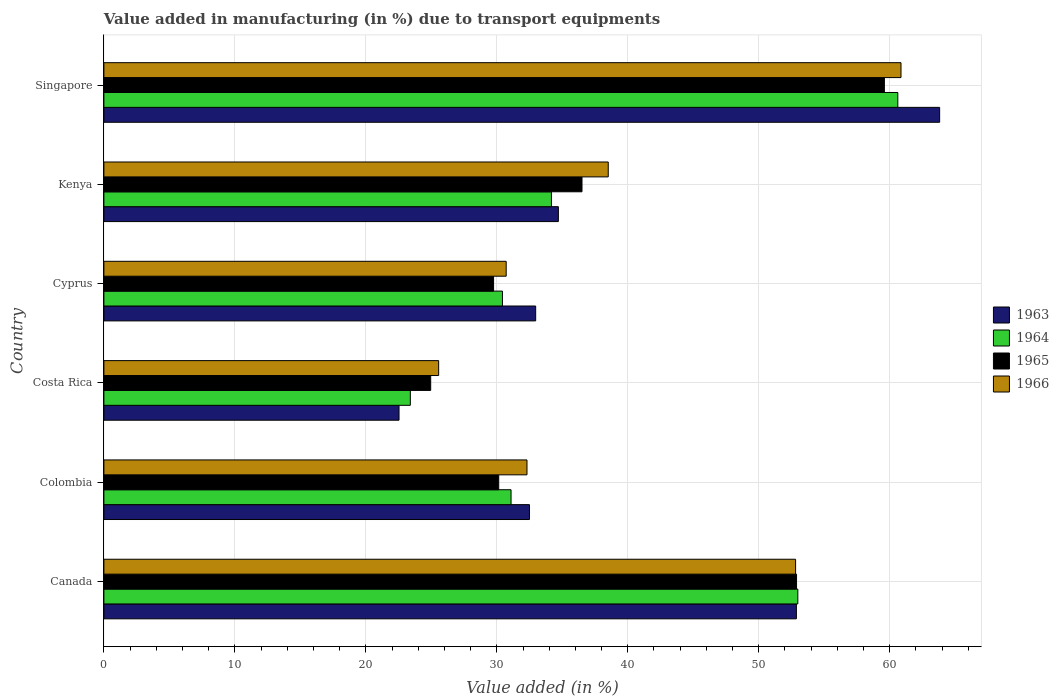How many groups of bars are there?
Offer a terse response. 6. Are the number of bars per tick equal to the number of legend labels?
Make the answer very short. Yes. Are the number of bars on each tick of the Y-axis equal?
Give a very brief answer. Yes. What is the label of the 1st group of bars from the top?
Provide a succinct answer. Singapore. In how many cases, is the number of bars for a given country not equal to the number of legend labels?
Provide a succinct answer. 0. What is the percentage of value added in manufacturing due to transport equipments in 1964 in Singapore?
Give a very brief answer. 60.62. Across all countries, what is the maximum percentage of value added in manufacturing due to transport equipments in 1965?
Offer a terse response. 59.59. Across all countries, what is the minimum percentage of value added in manufacturing due to transport equipments in 1966?
Offer a very short reply. 25.56. In which country was the percentage of value added in manufacturing due to transport equipments in 1965 maximum?
Provide a short and direct response. Singapore. What is the total percentage of value added in manufacturing due to transport equipments in 1966 in the graph?
Provide a short and direct response. 240.76. What is the difference between the percentage of value added in manufacturing due to transport equipments in 1963 in Canada and that in Singapore?
Give a very brief answer. -10.94. What is the difference between the percentage of value added in manufacturing due to transport equipments in 1965 in Costa Rica and the percentage of value added in manufacturing due to transport equipments in 1966 in Canada?
Your answer should be compact. -27.86. What is the average percentage of value added in manufacturing due to transport equipments in 1966 per country?
Your answer should be compact. 40.13. What is the difference between the percentage of value added in manufacturing due to transport equipments in 1965 and percentage of value added in manufacturing due to transport equipments in 1966 in Singapore?
Provide a short and direct response. -1.27. What is the ratio of the percentage of value added in manufacturing due to transport equipments in 1964 in Canada to that in Costa Rica?
Your response must be concise. 2.26. Is the percentage of value added in manufacturing due to transport equipments in 1965 in Colombia less than that in Cyprus?
Your answer should be compact. No. What is the difference between the highest and the second highest percentage of value added in manufacturing due to transport equipments in 1966?
Your answer should be very brief. 8.05. What is the difference between the highest and the lowest percentage of value added in manufacturing due to transport equipments in 1966?
Your answer should be compact. 35.3. In how many countries, is the percentage of value added in manufacturing due to transport equipments in 1966 greater than the average percentage of value added in manufacturing due to transport equipments in 1966 taken over all countries?
Make the answer very short. 2. What does the 3rd bar from the top in Colombia represents?
Provide a short and direct response. 1964. What does the 4th bar from the bottom in Singapore represents?
Your response must be concise. 1966. Does the graph contain any zero values?
Your answer should be very brief. No. Does the graph contain grids?
Provide a succinct answer. Yes. Where does the legend appear in the graph?
Ensure brevity in your answer.  Center right. How are the legend labels stacked?
Ensure brevity in your answer.  Vertical. What is the title of the graph?
Give a very brief answer. Value added in manufacturing (in %) due to transport equipments. What is the label or title of the X-axis?
Your answer should be compact. Value added (in %). What is the label or title of the Y-axis?
Your answer should be very brief. Country. What is the Value added (in %) of 1963 in Canada?
Ensure brevity in your answer.  52.87. What is the Value added (in %) in 1964 in Canada?
Ensure brevity in your answer.  52.98. What is the Value added (in %) in 1965 in Canada?
Your response must be concise. 52.89. What is the Value added (in %) in 1966 in Canada?
Keep it short and to the point. 52.81. What is the Value added (in %) of 1963 in Colombia?
Give a very brief answer. 32.49. What is the Value added (in %) in 1964 in Colombia?
Your answer should be compact. 31.09. What is the Value added (in %) in 1965 in Colombia?
Provide a succinct answer. 30.15. What is the Value added (in %) in 1966 in Colombia?
Ensure brevity in your answer.  32.3. What is the Value added (in %) in 1963 in Costa Rica?
Your response must be concise. 22.53. What is the Value added (in %) of 1964 in Costa Rica?
Offer a terse response. 23.4. What is the Value added (in %) in 1965 in Costa Rica?
Your response must be concise. 24.95. What is the Value added (in %) of 1966 in Costa Rica?
Your response must be concise. 25.56. What is the Value added (in %) in 1963 in Cyprus?
Provide a short and direct response. 32.97. What is the Value added (in %) in 1964 in Cyprus?
Your response must be concise. 30.43. What is the Value added (in %) of 1965 in Cyprus?
Offer a very short reply. 29.75. What is the Value added (in %) of 1966 in Cyprus?
Your answer should be compact. 30.72. What is the Value added (in %) of 1963 in Kenya?
Ensure brevity in your answer.  34.7. What is the Value added (in %) in 1964 in Kenya?
Your answer should be compact. 34.17. What is the Value added (in %) in 1965 in Kenya?
Keep it short and to the point. 36.5. What is the Value added (in %) in 1966 in Kenya?
Keep it short and to the point. 38.51. What is the Value added (in %) in 1963 in Singapore?
Give a very brief answer. 63.81. What is the Value added (in %) of 1964 in Singapore?
Your answer should be very brief. 60.62. What is the Value added (in %) of 1965 in Singapore?
Ensure brevity in your answer.  59.59. What is the Value added (in %) in 1966 in Singapore?
Offer a terse response. 60.86. Across all countries, what is the maximum Value added (in %) in 1963?
Your answer should be very brief. 63.81. Across all countries, what is the maximum Value added (in %) in 1964?
Give a very brief answer. 60.62. Across all countries, what is the maximum Value added (in %) in 1965?
Provide a short and direct response. 59.59. Across all countries, what is the maximum Value added (in %) of 1966?
Provide a succinct answer. 60.86. Across all countries, what is the minimum Value added (in %) in 1963?
Keep it short and to the point. 22.53. Across all countries, what is the minimum Value added (in %) of 1964?
Ensure brevity in your answer.  23.4. Across all countries, what is the minimum Value added (in %) of 1965?
Provide a short and direct response. 24.95. Across all countries, what is the minimum Value added (in %) of 1966?
Give a very brief answer. 25.56. What is the total Value added (in %) in 1963 in the graph?
Your answer should be very brief. 239.38. What is the total Value added (in %) in 1964 in the graph?
Give a very brief answer. 232.68. What is the total Value added (in %) in 1965 in the graph?
Give a very brief answer. 233.83. What is the total Value added (in %) of 1966 in the graph?
Give a very brief answer. 240.76. What is the difference between the Value added (in %) of 1963 in Canada and that in Colombia?
Your response must be concise. 20.38. What is the difference between the Value added (in %) in 1964 in Canada and that in Colombia?
Your answer should be very brief. 21.9. What is the difference between the Value added (in %) in 1965 in Canada and that in Colombia?
Your response must be concise. 22.74. What is the difference between the Value added (in %) in 1966 in Canada and that in Colombia?
Give a very brief answer. 20.51. What is the difference between the Value added (in %) of 1963 in Canada and that in Costa Rica?
Give a very brief answer. 30.34. What is the difference between the Value added (in %) of 1964 in Canada and that in Costa Rica?
Offer a very short reply. 29.59. What is the difference between the Value added (in %) in 1965 in Canada and that in Costa Rica?
Provide a succinct answer. 27.93. What is the difference between the Value added (in %) in 1966 in Canada and that in Costa Rica?
Your answer should be very brief. 27.25. What is the difference between the Value added (in %) of 1963 in Canada and that in Cyprus?
Your answer should be compact. 19.91. What is the difference between the Value added (in %) of 1964 in Canada and that in Cyprus?
Give a very brief answer. 22.55. What is the difference between the Value added (in %) in 1965 in Canada and that in Cyprus?
Provide a succinct answer. 23.13. What is the difference between the Value added (in %) in 1966 in Canada and that in Cyprus?
Make the answer very short. 22.1. What is the difference between the Value added (in %) of 1963 in Canada and that in Kenya?
Offer a very short reply. 18.17. What is the difference between the Value added (in %) of 1964 in Canada and that in Kenya?
Make the answer very short. 18.81. What is the difference between the Value added (in %) in 1965 in Canada and that in Kenya?
Give a very brief answer. 16.38. What is the difference between the Value added (in %) in 1966 in Canada and that in Kenya?
Offer a terse response. 14.3. What is the difference between the Value added (in %) of 1963 in Canada and that in Singapore?
Provide a succinct answer. -10.94. What is the difference between the Value added (in %) in 1964 in Canada and that in Singapore?
Your response must be concise. -7.63. What is the difference between the Value added (in %) in 1965 in Canada and that in Singapore?
Offer a very short reply. -6.71. What is the difference between the Value added (in %) in 1966 in Canada and that in Singapore?
Your response must be concise. -8.05. What is the difference between the Value added (in %) in 1963 in Colombia and that in Costa Rica?
Keep it short and to the point. 9.96. What is the difference between the Value added (in %) of 1964 in Colombia and that in Costa Rica?
Ensure brevity in your answer.  7.69. What is the difference between the Value added (in %) of 1965 in Colombia and that in Costa Rica?
Your answer should be very brief. 5.2. What is the difference between the Value added (in %) in 1966 in Colombia and that in Costa Rica?
Give a very brief answer. 6.74. What is the difference between the Value added (in %) in 1963 in Colombia and that in Cyprus?
Keep it short and to the point. -0.47. What is the difference between the Value added (in %) in 1964 in Colombia and that in Cyprus?
Your answer should be very brief. 0.66. What is the difference between the Value added (in %) of 1965 in Colombia and that in Cyprus?
Your answer should be compact. 0.39. What is the difference between the Value added (in %) of 1966 in Colombia and that in Cyprus?
Your response must be concise. 1.59. What is the difference between the Value added (in %) of 1963 in Colombia and that in Kenya?
Your response must be concise. -2.21. What is the difference between the Value added (in %) of 1964 in Colombia and that in Kenya?
Offer a terse response. -3.08. What is the difference between the Value added (in %) of 1965 in Colombia and that in Kenya?
Your response must be concise. -6.36. What is the difference between the Value added (in %) of 1966 in Colombia and that in Kenya?
Provide a short and direct response. -6.2. What is the difference between the Value added (in %) in 1963 in Colombia and that in Singapore?
Your response must be concise. -31.32. What is the difference between the Value added (in %) of 1964 in Colombia and that in Singapore?
Your answer should be compact. -29.53. What is the difference between the Value added (in %) of 1965 in Colombia and that in Singapore?
Provide a succinct answer. -29.45. What is the difference between the Value added (in %) of 1966 in Colombia and that in Singapore?
Ensure brevity in your answer.  -28.56. What is the difference between the Value added (in %) of 1963 in Costa Rica and that in Cyprus?
Your answer should be very brief. -10.43. What is the difference between the Value added (in %) in 1964 in Costa Rica and that in Cyprus?
Give a very brief answer. -7.03. What is the difference between the Value added (in %) of 1965 in Costa Rica and that in Cyprus?
Ensure brevity in your answer.  -4.8. What is the difference between the Value added (in %) in 1966 in Costa Rica and that in Cyprus?
Keep it short and to the point. -5.16. What is the difference between the Value added (in %) of 1963 in Costa Rica and that in Kenya?
Offer a terse response. -12.17. What is the difference between the Value added (in %) in 1964 in Costa Rica and that in Kenya?
Offer a very short reply. -10.77. What is the difference between the Value added (in %) in 1965 in Costa Rica and that in Kenya?
Provide a succinct answer. -11.55. What is the difference between the Value added (in %) in 1966 in Costa Rica and that in Kenya?
Ensure brevity in your answer.  -12.95. What is the difference between the Value added (in %) of 1963 in Costa Rica and that in Singapore?
Your answer should be very brief. -41.28. What is the difference between the Value added (in %) of 1964 in Costa Rica and that in Singapore?
Offer a very short reply. -37.22. What is the difference between the Value added (in %) of 1965 in Costa Rica and that in Singapore?
Offer a terse response. -34.64. What is the difference between the Value added (in %) of 1966 in Costa Rica and that in Singapore?
Your response must be concise. -35.3. What is the difference between the Value added (in %) of 1963 in Cyprus and that in Kenya?
Your answer should be very brief. -1.73. What is the difference between the Value added (in %) in 1964 in Cyprus and that in Kenya?
Provide a short and direct response. -3.74. What is the difference between the Value added (in %) in 1965 in Cyprus and that in Kenya?
Ensure brevity in your answer.  -6.75. What is the difference between the Value added (in %) of 1966 in Cyprus and that in Kenya?
Provide a succinct answer. -7.79. What is the difference between the Value added (in %) of 1963 in Cyprus and that in Singapore?
Provide a succinct answer. -30.84. What is the difference between the Value added (in %) of 1964 in Cyprus and that in Singapore?
Your answer should be compact. -30.19. What is the difference between the Value added (in %) in 1965 in Cyprus and that in Singapore?
Offer a terse response. -29.84. What is the difference between the Value added (in %) of 1966 in Cyprus and that in Singapore?
Ensure brevity in your answer.  -30.14. What is the difference between the Value added (in %) in 1963 in Kenya and that in Singapore?
Give a very brief answer. -29.11. What is the difference between the Value added (in %) of 1964 in Kenya and that in Singapore?
Give a very brief answer. -26.45. What is the difference between the Value added (in %) in 1965 in Kenya and that in Singapore?
Keep it short and to the point. -23.09. What is the difference between the Value added (in %) of 1966 in Kenya and that in Singapore?
Offer a very short reply. -22.35. What is the difference between the Value added (in %) in 1963 in Canada and the Value added (in %) in 1964 in Colombia?
Provide a short and direct response. 21.79. What is the difference between the Value added (in %) in 1963 in Canada and the Value added (in %) in 1965 in Colombia?
Make the answer very short. 22.73. What is the difference between the Value added (in %) in 1963 in Canada and the Value added (in %) in 1966 in Colombia?
Provide a short and direct response. 20.57. What is the difference between the Value added (in %) of 1964 in Canada and the Value added (in %) of 1965 in Colombia?
Ensure brevity in your answer.  22.84. What is the difference between the Value added (in %) of 1964 in Canada and the Value added (in %) of 1966 in Colombia?
Offer a terse response. 20.68. What is the difference between the Value added (in %) of 1965 in Canada and the Value added (in %) of 1966 in Colombia?
Your response must be concise. 20.58. What is the difference between the Value added (in %) in 1963 in Canada and the Value added (in %) in 1964 in Costa Rica?
Keep it short and to the point. 29.48. What is the difference between the Value added (in %) in 1963 in Canada and the Value added (in %) in 1965 in Costa Rica?
Provide a short and direct response. 27.92. What is the difference between the Value added (in %) of 1963 in Canada and the Value added (in %) of 1966 in Costa Rica?
Offer a terse response. 27.31. What is the difference between the Value added (in %) in 1964 in Canada and the Value added (in %) in 1965 in Costa Rica?
Provide a succinct answer. 28.03. What is the difference between the Value added (in %) in 1964 in Canada and the Value added (in %) in 1966 in Costa Rica?
Provide a short and direct response. 27.42. What is the difference between the Value added (in %) of 1965 in Canada and the Value added (in %) of 1966 in Costa Rica?
Give a very brief answer. 27.33. What is the difference between the Value added (in %) of 1963 in Canada and the Value added (in %) of 1964 in Cyprus?
Provide a short and direct response. 22.44. What is the difference between the Value added (in %) in 1963 in Canada and the Value added (in %) in 1965 in Cyprus?
Offer a terse response. 23.12. What is the difference between the Value added (in %) of 1963 in Canada and the Value added (in %) of 1966 in Cyprus?
Offer a very short reply. 22.16. What is the difference between the Value added (in %) in 1964 in Canada and the Value added (in %) in 1965 in Cyprus?
Offer a very short reply. 23.23. What is the difference between the Value added (in %) in 1964 in Canada and the Value added (in %) in 1966 in Cyprus?
Make the answer very short. 22.27. What is the difference between the Value added (in %) of 1965 in Canada and the Value added (in %) of 1966 in Cyprus?
Offer a terse response. 22.17. What is the difference between the Value added (in %) of 1963 in Canada and the Value added (in %) of 1964 in Kenya?
Your answer should be compact. 18.7. What is the difference between the Value added (in %) in 1963 in Canada and the Value added (in %) in 1965 in Kenya?
Your answer should be compact. 16.37. What is the difference between the Value added (in %) in 1963 in Canada and the Value added (in %) in 1966 in Kenya?
Make the answer very short. 14.37. What is the difference between the Value added (in %) in 1964 in Canada and the Value added (in %) in 1965 in Kenya?
Provide a succinct answer. 16.48. What is the difference between the Value added (in %) of 1964 in Canada and the Value added (in %) of 1966 in Kenya?
Your answer should be compact. 14.47. What is the difference between the Value added (in %) in 1965 in Canada and the Value added (in %) in 1966 in Kenya?
Provide a short and direct response. 14.38. What is the difference between the Value added (in %) of 1963 in Canada and the Value added (in %) of 1964 in Singapore?
Make the answer very short. -7.74. What is the difference between the Value added (in %) of 1963 in Canada and the Value added (in %) of 1965 in Singapore?
Provide a short and direct response. -6.72. What is the difference between the Value added (in %) in 1963 in Canada and the Value added (in %) in 1966 in Singapore?
Ensure brevity in your answer.  -7.99. What is the difference between the Value added (in %) in 1964 in Canada and the Value added (in %) in 1965 in Singapore?
Offer a terse response. -6.61. What is the difference between the Value added (in %) of 1964 in Canada and the Value added (in %) of 1966 in Singapore?
Provide a short and direct response. -7.88. What is the difference between the Value added (in %) in 1965 in Canada and the Value added (in %) in 1966 in Singapore?
Provide a short and direct response. -7.97. What is the difference between the Value added (in %) in 1963 in Colombia and the Value added (in %) in 1964 in Costa Rica?
Ensure brevity in your answer.  9.1. What is the difference between the Value added (in %) in 1963 in Colombia and the Value added (in %) in 1965 in Costa Rica?
Provide a short and direct response. 7.54. What is the difference between the Value added (in %) of 1963 in Colombia and the Value added (in %) of 1966 in Costa Rica?
Your response must be concise. 6.93. What is the difference between the Value added (in %) of 1964 in Colombia and the Value added (in %) of 1965 in Costa Rica?
Give a very brief answer. 6.14. What is the difference between the Value added (in %) in 1964 in Colombia and the Value added (in %) in 1966 in Costa Rica?
Provide a short and direct response. 5.53. What is the difference between the Value added (in %) of 1965 in Colombia and the Value added (in %) of 1966 in Costa Rica?
Make the answer very short. 4.59. What is the difference between the Value added (in %) in 1963 in Colombia and the Value added (in %) in 1964 in Cyprus?
Provide a succinct answer. 2.06. What is the difference between the Value added (in %) in 1963 in Colombia and the Value added (in %) in 1965 in Cyprus?
Give a very brief answer. 2.74. What is the difference between the Value added (in %) of 1963 in Colombia and the Value added (in %) of 1966 in Cyprus?
Provide a short and direct response. 1.78. What is the difference between the Value added (in %) of 1964 in Colombia and the Value added (in %) of 1965 in Cyprus?
Your answer should be compact. 1.33. What is the difference between the Value added (in %) in 1964 in Colombia and the Value added (in %) in 1966 in Cyprus?
Provide a succinct answer. 0.37. What is the difference between the Value added (in %) of 1965 in Colombia and the Value added (in %) of 1966 in Cyprus?
Provide a short and direct response. -0.57. What is the difference between the Value added (in %) in 1963 in Colombia and the Value added (in %) in 1964 in Kenya?
Offer a terse response. -1.68. What is the difference between the Value added (in %) of 1963 in Colombia and the Value added (in %) of 1965 in Kenya?
Provide a succinct answer. -4.01. What is the difference between the Value added (in %) in 1963 in Colombia and the Value added (in %) in 1966 in Kenya?
Your response must be concise. -6.01. What is the difference between the Value added (in %) in 1964 in Colombia and the Value added (in %) in 1965 in Kenya?
Provide a succinct answer. -5.42. What is the difference between the Value added (in %) of 1964 in Colombia and the Value added (in %) of 1966 in Kenya?
Offer a terse response. -7.42. What is the difference between the Value added (in %) of 1965 in Colombia and the Value added (in %) of 1966 in Kenya?
Keep it short and to the point. -8.36. What is the difference between the Value added (in %) in 1963 in Colombia and the Value added (in %) in 1964 in Singapore?
Make the answer very short. -28.12. What is the difference between the Value added (in %) of 1963 in Colombia and the Value added (in %) of 1965 in Singapore?
Keep it short and to the point. -27.1. What is the difference between the Value added (in %) in 1963 in Colombia and the Value added (in %) in 1966 in Singapore?
Your response must be concise. -28.37. What is the difference between the Value added (in %) of 1964 in Colombia and the Value added (in %) of 1965 in Singapore?
Your answer should be compact. -28.51. What is the difference between the Value added (in %) of 1964 in Colombia and the Value added (in %) of 1966 in Singapore?
Ensure brevity in your answer.  -29.77. What is the difference between the Value added (in %) in 1965 in Colombia and the Value added (in %) in 1966 in Singapore?
Offer a very short reply. -30.71. What is the difference between the Value added (in %) of 1963 in Costa Rica and the Value added (in %) of 1964 in Cyprus?
Offer a very short reply. -7.9. What is the difference between the Value added (in %) in 1963 in Costa Rica and the Value added (in %) in 1965 in Cyprus?
Your answer should be compact. -7.22. What is the difference between the Value added (in %) in 1963 in Costa Rica and the Value added (in %) in 1966 in Cyprus?
Provide a short and direct response. -8.18. What is the difference between the Value added (in %) of 1964 in Costa Rica and the Value added (in %) of 1965 in Cyprus?
Your answer should be compact. -6.36. What is the difference between the Value added (in %) in 1964 in Costa Rica and the Value added (in %) in 1966 in Cyprus?
Provide a succinct answer. -7.32. What is the difference between the Value added (in %) in 1965 in Costa Rica and the Value added (in %) in 1966 in Cyprus?
Make the answer very short. -5.77. What is the difference between the Value added (in %) of 1963 in Costa Rica and the Value added (in %) of 1964 in Kenya?
Your answer should be very brief. -11.64. What is the difference between the Value added (in %) in 1963 in Costa Rica and the Value added (in %) in 1965 in Kenya?
Provide a succinct answer. -13.97. What is the difference between the Value added (in %) of 1963 in Costa Rica and the Value added (in %) of 1966 in Kenya?
Provide a succinct answer. -15.97. What is the difference between the Value added (in %) in 1964 in Costa Rica and the Value added (in %) in 1965 in Kenya?
Your answer should be very brief. -13.11. What is the difference between the Value added (in %) in 1964 in Costa Rica and the Value added (in %) in 1966 in Kenya?
Your answer should be compact. -15.11. What is the difference between the Value added (in %) of 1965 in Costa Rica and the Value added (in %) of 1966 in Kenya?
Make the answer very short. -13.56. What is the difference between the Value added (in %) of 1963 in Costa Rica and the Value added (in %) of 1964 in Singapore?
Your answer should be very brief. -38.08. What is the difference between the Value added (in %) in 1963 in Costa Rica and the Value added (in %) in 1965 in Singapore?
Your answer should be very brief. -37.06. What is the difference between the Value added (in %) of 1963 in Costa Rica and the Value added (in %) of 1966 in Singapore?
Provide a succinct answer. -38.33. What is the difference between the Value added (in %) of 1964 in Costa Rica and the Value added (in %) of 1965 in Singapore?
Your answer should be compact. -36.19. What is the difference between the Value added (in %) of 1964 in Costa Rica and the Value added (in %) of 1966 in Singapore?
Give a very brief answer. -37.46. What is the difference between the Value added (in %) of 1965 in Costa Rica and the Value added (in %) of 1966 in Singapore?
Keep it short and to the point. -35.91. What is the difference between the Value added (in %) of 1963 in Cyprus and the Value added (in %) of 1964 in Kenya?
Your answer should be compact. -1.2. What is the difference between the Value added (in %) of 1963 in Cyprus and the Value added (in %) of 1965 in Kenya?
Keep it short and to the point. -3.54. What is the difference between the Value added (in %) of 1963 in Cyprus and the Value added (in %) of 1966 in Kenya?
Offer a terse response. -5.54. What is the difference between the Value added (in %) in 1964 in Cyprus and the Value added (in %) in 1965 in Kenya?
Offer a terse response. -6.07. What is the difference between the Value added (in %) of 1964 in Cyprus and the Value added (in %) of 1966 in Kenya?
Offer a very short reply. -8.08. What is the difference between the Value added (in %) of 1965 in Cyprus and the Value added (in %) of 1966 in Kenya?
Give a very brief answer. -8.75. What is the difference between the Value added (in %) of 1963 in Cyprus and the Value added (in %) of 1964 in Singapore?
Make the answer very short. -27.65. What is the difference between the Value added (in %) in 1963 in Cyprus and the Value added (in %) in 1965 in Singapore?
Your response must be concise. -26.62. What is the difference between the Value added (in %) in 1963 in Cyprus and the Value added (in %) in 1966 in Singapore?
Provide a succinct answer. -27.89. What is the difference between the Value added (in %) of 1964 in Cyprus and the Value added (in %) of 1965 in Singapore?
Your response must be concise. -29.16. What is the difference between the Value added (in %) of 1964 in Cyprus and the Value added (in %) of 1966 in Singapore?
Provide a succinct answer. -30.43. What is the difference between the Value added (in %) in 1965 in Cyprus and the Value added (in %) in 1966 in Singapore?
Make the answer very short. -31.11. What is the difference between the Value added (in %) of 1963 in Kenya and the Value added (in %) of 1964 in Singapore?
Your response must be concise. -25.92. What is the difference between the Value added (in %) of 1963 in Kenya and the Value added (in %) of 1965 in Singapore?
Provide a succinct answer. -24.89. What is the difference between the Value added (in %) of 1963 in Kenya and the Value added (in %) of 1966 in Singapore?
Keep it short and to the point. -26.16. What is the difference between the Value added (in %) in 1964 in Kenya and the Value added (in %) in 1965 in Singapore?
Make the answer very short. -25.42. What is the difference between the Value added (in %) of 1964 in Kenya and the Value added (in %) of 1966 in Singapore?
Keep it short and to the point. -26.69. What is the difference between the Value added (in %) of 1965 in Kenya and the Value added (in %) of 1966 in Singapore?
Your answer should be compact. -24.36. What is the average Value added (in %) in 1963 per country?
Keep it short and to the point. 39.9. What is the average Value added (in %) in 1964 per country?
Your answer should be compact. 38.78. What is the average Value added (in %) of 1965 per country?
Offer a very short reply. 38.97. What is the average Value added (in %) of 1966 per country?
Offer a very short reply. 40.13. What is the difference between the Value added (in %) of 1963 and Value added (in %) of 1964 in Canada?
Your answer should be compact. -0.11. What is the difference between the Value added (in %) of 1963 and Value added (in %) of 1965 in Canada?
Give a very brief answer. -0.01. What is the difference between the Value added (in %) of 1963 and Value added (in %) of 1966 in Canada?
Your answer should be compact. 0.06. What is the difference between the Value added (in %) of 1964 and Value added (in %) of 1965 in Canada?
Give a very brief answer. 0.1. What is the difference between the Value added (in %) of 1964 and Value added (in %) of 1966 in Canada?
Provide a short and direct response. 0.17. What is the difference between the Value added (in %) of 1965 and Value added (in %) of 1966 in Canada?
Give a very brief answer. 0.07. What is the difference between the Value added (in %) of 1963 and Value added (in %) of 1964 in Colombia?
Keep it short and to the point. 1.41. What is the difference between the Value added (in %) in 1963 and Value added (in %) in 1965 in Colombia?
Provide a succinct answer. 2.35. What is the difference between the Value added (in %) in 1963 and Value added (in %) in 1966 in Colombia?
Your answer should be very brief. 0.19. What is the difference between the Value added (in %) of 1964 and Value added (in %) of 1965 in Colombia?
Ensure brevity in your answer.  0.94. What is the difference between the Value added (in %) of 1964 and Value added (in %) of 1966 in Colombia?
Provide a succinct answer. -1.22. What is the difference between the Value added (in %) of 1965 and Value added (in %) of 1966 in Colombia?
Provide a succinct answer. -2.16. What is the difference between the Value added (in %) in 1963 and Value added (in %) in 1964 in Costa Rica?
Make the answer very short. -0.86. What is the difference between the Value added (in %) of 1963 and Value added (in %) of 1965 in Costa Rica?
Your response must be concise. -2.42. What is the difference between the Value added (in %) of 1963 and Value added (in %) of 1966 in Costa Rica?
Give a very brief answer. -3.03. What is the difference between the Value added (in %) of 1964 and Value added (in %) of 1965 in Costa Rica?
Give a very brief answer. -1.55. What is the difference between the Value added (in %) in 1964 and Value added (in %) in 1966 in Costa Rica?
Give a very brief answer. -2.16. What is the difference between the Value added (in %) of 1965 and Value added (in %) of 1966 in Costa Rica?
Keep it short and to the point. -0.61. What is the difference between the Value added (in %) of 1963 and Value added (in %) of 1964 in Cyprus?
Ensure brevity in your answer.  2.54. What is the difference between the Value added (in %) in 1963 and Value added (in %) in 1965 in Cyprus?
Your answer should be compact. 3.21. What is the difference between the Value added (in %) in 1963 and Value added (in %) in 1966 in Cyprus?
Make the answer very short. 2.25. What is the difference between the Value added (in %) in 1964 and Value added (in %) in 1965 in Cyprus?
Your answer should be compact. 0.68. What is the difference between the Value added (in %) in 1964 and Value added (in %) in 1966 in Cyprus?
Provide a short and direct response. -0.29. What is the difference between the Value added (in %) of 1965 and Value added (in %) of 1966 in Cyprus?
Keep it short and to the point. -0.96. What is the difference between the Value added (in %) of 1963 and Value added (in %) of 1964 in Kenya?
Ensure brevity in your answer.  0.53. What is the difference between the Value added (in %) in 1963 and Value added (in %) in 1965 in Kenya?
Give a very brief answer. -1.8. What is the difference between the Value added (in %) in 1963 and Value added (in %) in 1966 in Kenya?
Make the answer very short. -3.81. What is the difference between the Value added (in %) of 1964 and Value added (in %) of 1965 in Kenya?
Give a very brief answer. -2.33. What is the difference between the Value added (in %) of 1964 and Value added (in %) of 1966 in Kenya?
Ensure brevity in your answer.  -4.34. What is the difference between the Value added (in %) of 1965 and Value added (in %) of 1966 in Kenya?
Provide a succinct answer. -2. What is the difference between the Value added (in %) in 1963 and Value added (in %) in 1964 in Singapore?
Keep it short and to the point. 3.19. What is the difference between the Value added (in %) of 1963 and Value added (in %) of 1965 in Singapore?
Offer a terse response. 4.22. What is the difference between the Value added (in %) of 1963 and Value added (in %) of 1966 in Singapore?
Your answer should be very brief. 2.95. What is the difference between the Value added (in %) of 1964 and Value added (in %) of 1965 in Singapore?
Ensure brevity in your answer.  1.03. What is the difference between the Value added (in %) in 1964 and Value added (in %) in 1966 in Singapore?
Your answer should be compact. -0.24. What is the difference between the Value added (in %) of 1965 and Value added (in %) of 1966 in Singapore?
Offer a terse response. -1.27. What is the ratio of the Value added (in %) of 1963 in Canada to that in Colombia?
Provide a short and direct response. 1.63. What is the ratio of the Value added (in %) in 1964 in Canada to that in Colombia?
Ensure brevity in your answer.  1.7. What is the ratio of the Value added (in %) in 1965 in Canada to that in Colombia?
Give a very brief answer. 1.75. What is the ratio of the Value added (in %) in 1966 in Canada to that in Colombia?
Your answer should be compact. 1.63. What is the ratio of the Value added (in %) of 1963 in Canada to that in Costa Rica?
Your answer should be very brief. 2.35. What is the ratio of the Value added (in %) of 1964 in Canada to that in Costa Rica?
Your response must be concise. 2.26. What is the ratio of the Value added (in %) of 1965 in Canada to that in Costa Rica?
Provide a succinct answer. 2.12. What is the ratio of the Value added (in %) of 1966 in Canada to that in Costa Rica?
Your answer should be compact. 2.07. What is the ratio of the Value added (in %) of 1963 in Canada to that in Cyprus?
Keep it short and to the point. 1.6. What is the ratio of the Value added (in %) of 1964 in Canada to that in Cyprus?
Make the answer very short. 1.74. What is the ratio of the Value added (in %) of 1965 in Canada to that in Cyprus?
Keep it short and to the point. 1.78. What is the ratio of the Value added (in %) in 1966 in Canada to that in Cyprus?
Ensure brevity in your answer.  1.72. What is the ratio of the Value added (in %) of 1963 in Canada to that in Kenya?
Keep it short and to the point. 1.52. What is the ratio of the Value added (in %) of 1964 in Canada to that in Kenya?
Make the answer very short. 1.55. What is the ratio of the Value added (in %) in 1965 in Canada to that in Kenya?
Your response must be concise. 1.45. What is the ratio of the Value added (in %) in 1966 in Canada to that in Kenya?
Offer a terse response. 1.37. What is the ratio of the Value added (in %) of 1963 in Canada to that in Singapore?
Offer a very short reply. 0.83. What is the ratio of the Value added (in %) in 1964 in Canada to that in Singapore?
Offer a very short reply. 0.87. What is the ratio of the Value added (in %) in 1965 in Canada to that in Singapore?
Your answer should be compact. 0.89. What is the ratio of the Value added (in %) in 1966 in Canada to that in Singapore?
Provide a short and direct response. 0.87. What is the ratio of the Value added (in %) of 1963 in Colombia to that in Costa Rica?
Keep it short and to the point. 1.44. What is the ratio of the Value added (in %) in 1964 in Colombia to that in Costa Rica?
Provide a short and direct response. 1.33. What is the ratio of the Value added (in %) in 1965 in Colombia to that in Costa Rica?
Provide a succinct answer. 1.21. What is the ratio of the Value added (in %) of 1966 in Colombia to that in Costa Rica?
Provide a short and direct response. 1.26. What is the ratio of the Value added (in %) in 1963 in Colombia to that in Cyprus?
Provide a succinct answer. 0.99. What is the ratio of the Value added (in %) of 1964 in Colombia to that in Cyprus?
Your answer should be compact. 1.02. What is the ratio of the Value added (in %) in 1965 in Colombia to that in Cyprus?
Your response must be concise. 1.01. What is the ratio of the Value added (in %) of 1966 in Colombia to that in Cyprus?
Provide a succinct answer. 1.05. What is the ratio of the Value added (in %) of 1963 in Colombia to that in Kenya?
Make the answer very short. 0.94. What is the ratio of the Value added (in %) of 1964 in Colombia to that in Kenya?
Ensure brevity in your answer.  0.91. What is the ratio of the Value added (in %) in 1965 in Colombia to that in Kenya?
Offer a very short reply. 0.83. What is the ratio of the Value added (in %) of 1966 in Colombia to that in Kenya?
Keep it short and to the point. 0.84. What is the ratio of the Value added (in %) in 1963 in Colombia to that in Singapore?
Ensure brevity in your answer.  0.51. What is the ratio of the Value added (in %) of 1964 in Colombia to that in Singapore?
Give a very brief answer. 0.51. What is the ratio of the Value added (in %) in 1965 in Colombia to that in Singapore?
Offer a very short reply. 0.51. What is the ratio of the Value added (in %) of 1966 in Colombia to that in Singapore?
Ensure brevity in your answer.  0.53. What is the ratio of the Value added (in %) in 1963 in Costa Rica to that in Cyprus?
Offer a terse response. 0.68. What is the ratio of the Value added (in %) of 1964 in Costa Rica to that in Cyprus?
Your answer should be very brief. 0.77. What is the ratio of the Value added (in %) of 1965 in Costa Rica to that in Cyprus?
Your answer should be very brief. 0.84. What is the ratio of the Value added (in %) of 1966 in Costa Rica to that in Cyprus?
Ensure brevity in your answer.  0.83. What is the ratio of the Value added (in %) of 1963 in Costa Rica to that in Kenya?
Offer a very short reply. 0.65. What is the ratio of the Value added (in %) in 1964 in Costa Rica to that in Kenya?
Your answer should be very brief. 0.68. What is the ratio of the Value added (in %) of 1965 in Costa Rica to that in Kenya?
Provide a succinct answer. 0.68. What is the ratio of the Value added (in %) of 1966 in Costa Rica to that in Kenya?
Your answer should be compact. 0.66. What is the ratio of the Value added (in %) of 1963 in Costa Rica to that in Singapore?
Offer a very short reply. 0.35. What is the ratio of the Value added (in %) of 1964 in Costa Rica to that in Singapore?
Your answer should be very brief. 0.39. What is the ratio of the Value added (in %) in 1965 in Costa Rica to that in Singapore?
Your answer should be compact. 0.42. What is the ratio of the Value added (in %) of 1966 in Costa Rica to that in Singapore?
Give a very brief answer. 0.42. What is the ratio of the Value added (in %) of 1963 in Cyprus to that in Kenya?
Offer a terse response. 0.95. What is the ratio of the Value added (in %) in 1964 in Cyprus to that in Kenya?
Ensure brevity in your answer.  0.89. What is the ratio of the Value added (in %) in 1965 in Cyprus to that in Kenya?
Give a very brief answer. 0.82. What is the ratio of the Value added (in %) in 1966 in Cyprus to that in Kenya?
Your response must be concise. 0.8. What is the ratio of the Value added (in %) in 1963 in Cyprus to that in Singapore?
Provide a succinct answer. 0.52. What is the ratio of the Value added (in %) in 1964 in Cyprus to that in Singapore?
Provide a succinct answer. 0.5. What is the ratio of the Value added (in %) in 1965 in Cyprus to that in Singapore?
Offer a terse response. 0.5. What is the ratio of the Value added (in %) in 1966 in Cyprus to that in Singapore?
Your answer should be very brief. 0.5. What is the ratio of the Value added (in %) of 1963 in Kenya to that in Singapore?
Ensure brevity in your answer.  0.54. What is the ratio of the Value added (in %) of 1964 in Kenya to that in Singapore?
Offer a terse response. 0.56. What is the ratio of the Value added (in %) of 1965 in Kenya to that in Singapore?
Your answer should be very brief. 0.61. What is the ratio of the Value added (in %) in 1966 in Kenya to that in Singapore?
Provide a succinct answer. 0.63. What is the difference between the highest and the second highest Value added (in %) of 1963?
Offer a terse response. 10.94. What is the difference between the highest and the second highest Value added (in %) of 1964?
Provide a succinct answer. 7.63. What is the difference between the highest and the second highest Value added (in %) of 1965?
Provide a short and direct response. 6.71. What is the difference between the highest and the second highest Value added (in %) in 1966?
Your response must be concise. 8.05. What is the difference between the highest and the lowest Value added (in %) in 1963?
Offer a terse response. 41.28. What is the difference between the highest and the lowest Value added (in %) in 1964?
Offer a very short reply. 37.22. What is the difference between the highest and the lowest Value added (in %) in 1965?
Make the answer very short. 34.64. What is the difference between the highest and the lowest Value added (in %) of 1966?
Offer a very short reply. 35.3. 